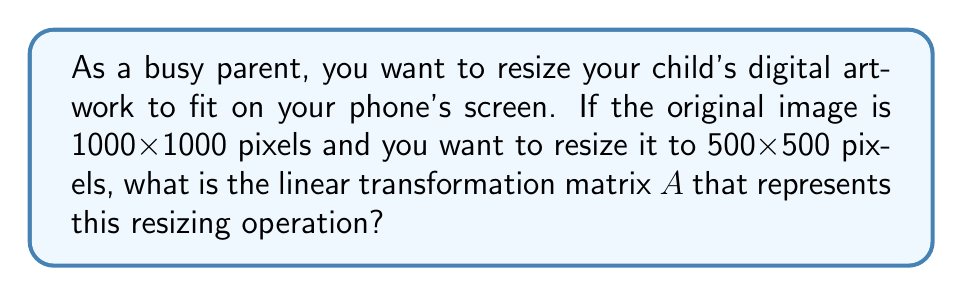Give your solution to this math problem. Let's approach this step-by-step:

1) In digital image processing, resizing an image is a linear transformation that can be represented by a matrix.

2) The transformation we're looking for scales both the x and y coordinates by the same factor.

3) To find the scaling factor:
   New size / Original size = 500 / 1000 = 1/2 = 0.5

4) The general form of a 2D scaling matrix is:
   $$A = \begin{bmatrix} s_x & 0 \\ 0 & s_y \end{bmatrix}$$
   where $s_x$ is the scaling factor for x-direction and $s_y$ is for y-direction.

5) In this case, we're scaling both dimensions equally, so $s_x = s_y = 0.5$

6) Therefore, the linear transformation matrix A is:
   $$A = \begin{bmatrix} 0.5 & 0 \\ 0 & 0.5 \end{bmatrix}$$

This matrix, when applied to each pixel coordinate $(x, y)$ in the original image, will produce the corresponding coordinate in the resized image.
Answer: $$A = \begin{bmatrix} 0.5 & 0 \\ 0 & 0.5 \end{bmatrix}$$ 